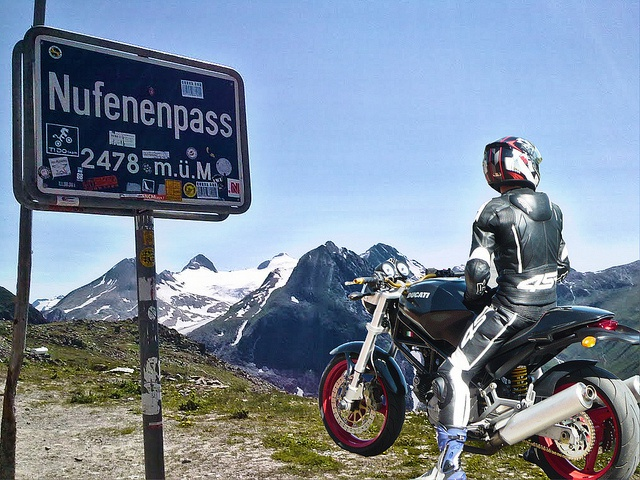Describe the objects in this image and their specific colors. I can see motorcycle in gray, black, lightgray, and darkgray tones and people in gray, black, white, and darkgray tones in this image. 